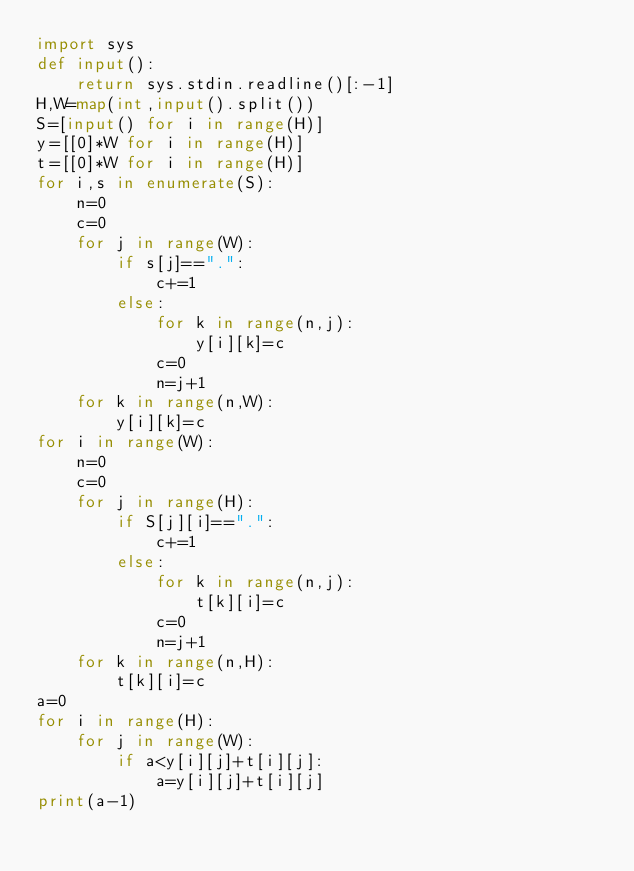<code> <loc_0><loc_0><loc_500><loc_500><_Python_>import sys
def input():
    return sys.stdin.readline()[:-1]
H,W=map(int,input().split())
S=[input() for i in range(H)]
y=[[0]*W for i in range(H)]
t=[[0]*W for i in range(H)]
for i,s in enumerate(S):
    n=0
    c=0
    for j in range(W):
        if s[j]==".":
            c+=1
        else:
            for k in range(n,j):
                y[i][k]=c
            c=0
            n=j+1
    for k in range(n,W):
        y[i][k]=c
for i in range(W):
    n=0
    c=0
    for j in range(H):
        if S[j][i]==".":
            c+=1
        else:
            for k in range(n,j):
                t[k][i]=c
            c=0
            n=j+1
    for k in range(n,H):
        t[k][i]=c
a=0
for i in range(H):
    for j in range(W):
        if a<y[i][j]+t[i][j]:
            a=y[i][j]+t[i][j]
print(a-1)</code> 